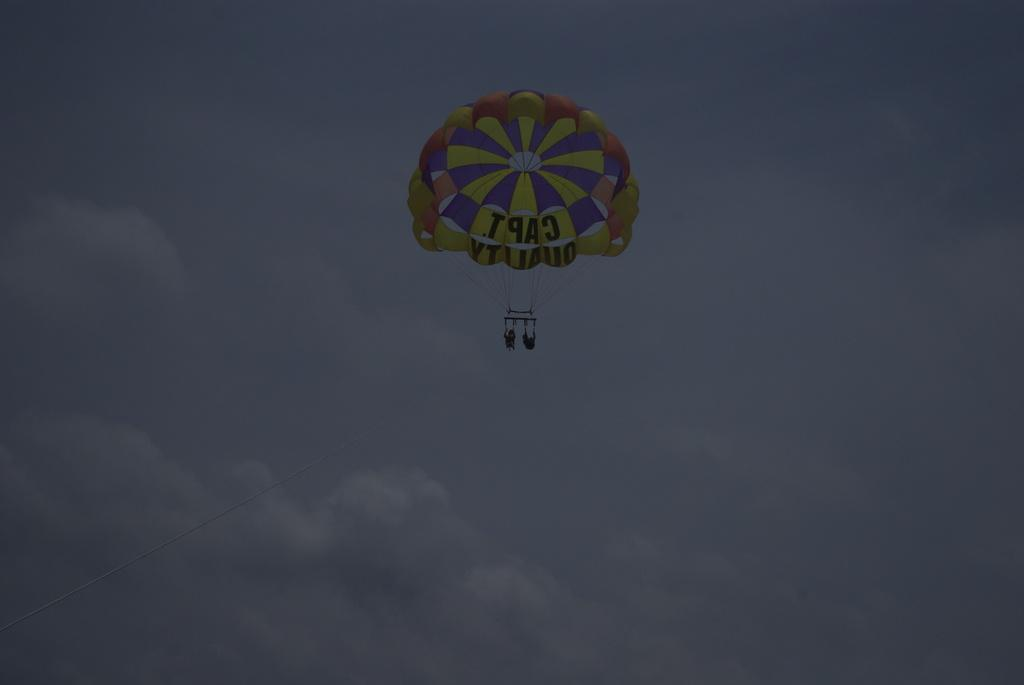How many people are in the image? There are two persons in the image. What are the persons doing in the image? The persons are flying with the help of parachutes. What can be seen in the background of the image? The sky is visible in the image. How would you describe the sky in the image? The sky appears to be clouded. What type of feast is being prepared in the image? There is no feast present in the image; it features two persons flying with parachutes against a clouded sky. What is the cause of the clouded sky in the image? The cause of the clouded sky is not mentioned in the image, but it could be due to weather conditions or the time of day. 